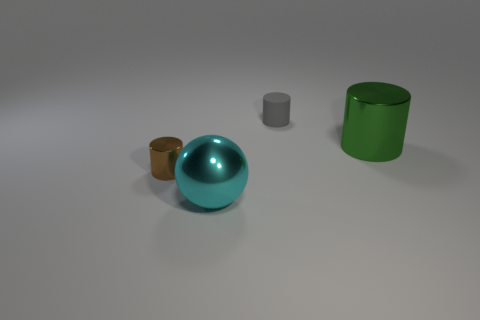Subtract all gray cylinders. How many cylinders are left? 2 Subtract 1 spheres. How many spheres are left? 0 Subtract all green cylinders. How many cylinders are left? 2 Add 1 large things. How many objects exist? 5 Subtract all large gray matte spheres. Subtract all big green things. How many objects are left? 3 Add 2 small brown things. How many small brown things are left? 3 Add 4 balls. How many balls exist? 5 Subtract 0 red cubes. How many objects are left? 4 Subtract all cylinders. How many objects are left? 1 Subtract all purple spheres. Subtract all yellow cylinders. How many spheres are left? 1 